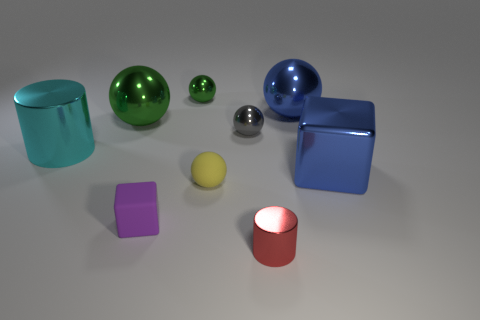Do the metallic cube and the small rubber sphere have the same color?
Your response must be concise. No. There is a large green object that is the same material as the small red object; what shape is it?
Make the answer very short. Sphere. What number of large purple matte things have the same shape as the large green object?
Keep it short and to the point. 0. The purple thing behind the metallic thing in front of the small purple block is what shape?
Your answer should be very brief. Cube. Does the ball that is in front of the blue metallic block have the same size as the purple cube?
Your answer should be very brief. Yes. There is a metallic thing that is on the left side of the large blue metal sphere and behind the large green shiny thing; how big is it?
Provide a short and direct response. Small. How many balls have the same size as the cyan shiny object?
Make the answer very short. 2. There is a blue object that is in front of the large green object; what number of red cylinders are to the right of it?
Provide a short and direct response. 0. There is a metal cylinder that is left of the big green thing; does it have the same color as the tiny cylinder?
Provide a succinct answer. No. Are there any large metal balls that are to the right of the tiny thing in front of the tiny purple matte object on the right side of the big cyan metallic cylinder?
Offer a terse response. Yes. 